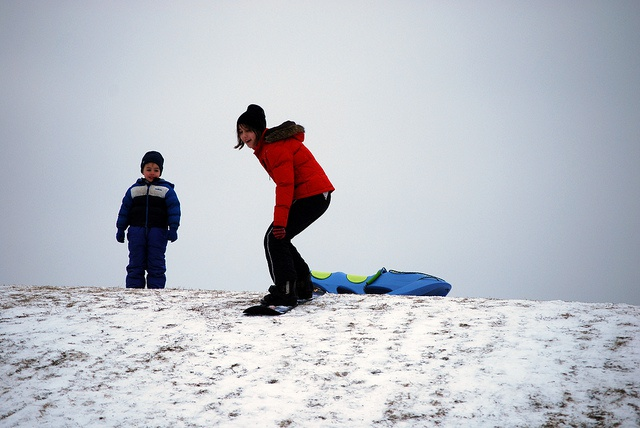Describe the objects in this image and their specific colors. I can see people in darkgray, black, maroon, and lightgray tones, people in darkgray, black, navy, and gray tones, snowboard in darkgray, black, navy, and gray tones, and surfboard in darkgray, black, and gray tones in this image. 